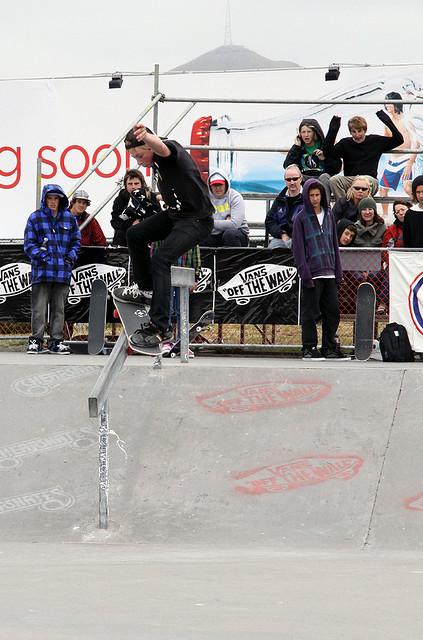What is the man sliding down?
Keep it brief. Rail. Is there a spectator in white?
Quick response, please. No. Are there many people in the background?
Give a very brief answer. Yes. What is the man riding?
Be succinct. Skateboard. 